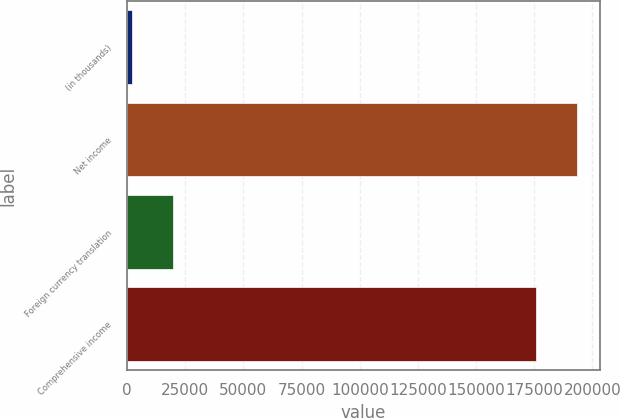Convert chart to OTSL. <chart><loc_0><loc_0><loc_500><loc_500><bar_chart><fcel>(in thousands)<fcel>Net income<fcel>Foreign currency translation<fcel>Comprehensive income<nl><fcel>2011<fcel>193455<fcel>19877.4<fcel>175589<nl></chart> 